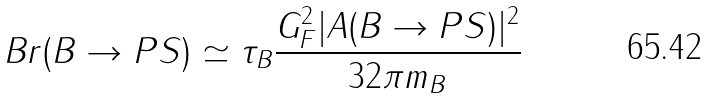Convert formula to latex. <formula><loc_0><loc_0><loc_500><loc_500>B r ( B \to P S ) \simeq \tau _ { B } \frac { G ^ { 2 } _ { F } | A ( B \to P S ) | ^ { 2 } } { 3 2 \pi m _ { B } }</formula> 